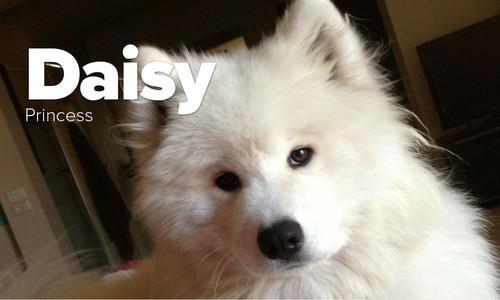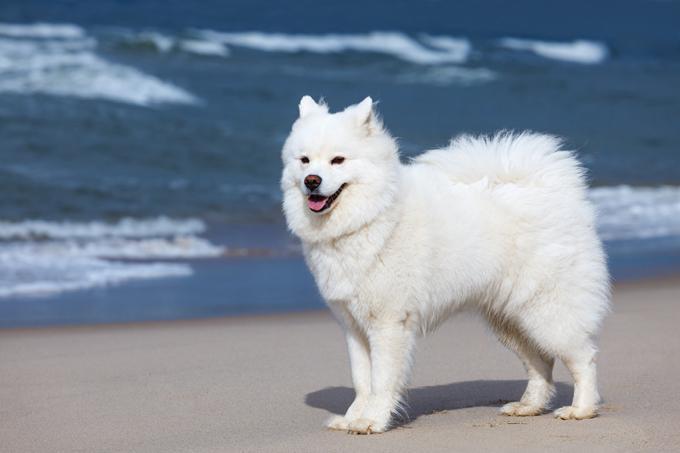The first image is the image on the left, the second image is the image on the right. Evaluate the accuracy of this statement regarding the images: "One dog is outdoors, and one dog is indoors.". Is it true? Answer yes or no. Yes. The first image is the image on the left, the second image is the image on the right. Considering the images on both sides, is "An image shows one white dog wearing something other than a dog collar." valid? Answer yes or no. No. 